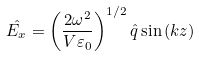<formula> <loc_0><loc_0><loc_500><loc_500>\hat { E _ { x } } = \left ( \frac { 2 \omega ^ { 2 } } { V \varepsilon _ { 0 } } \right ) ^ { 1 / 2 } \hat { q } \sin \left ( k z \right )</formula> 